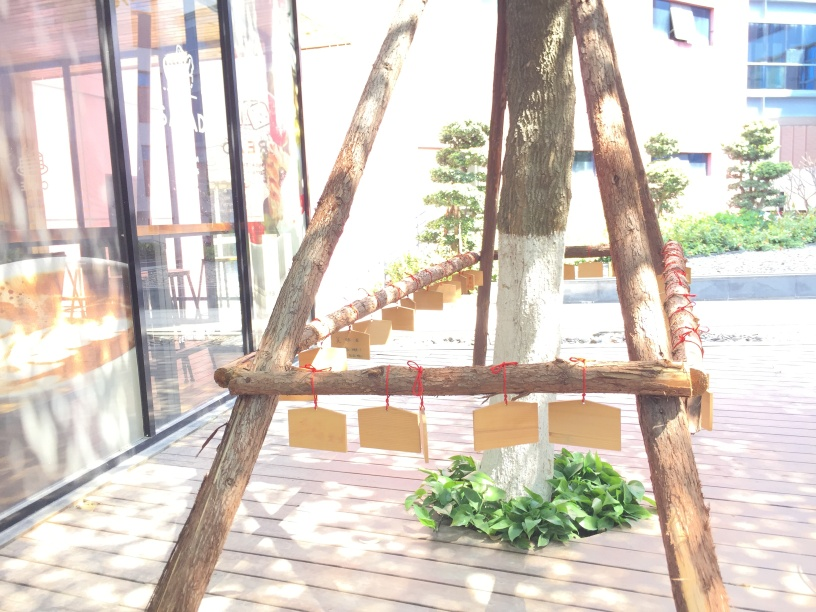How would you describe the atmosphere of the place where this image was taken? The image suggests a relaxed and informal outdoor atmosphere, likely part of a café or communal space with a focus on natural elements and open-air design. 